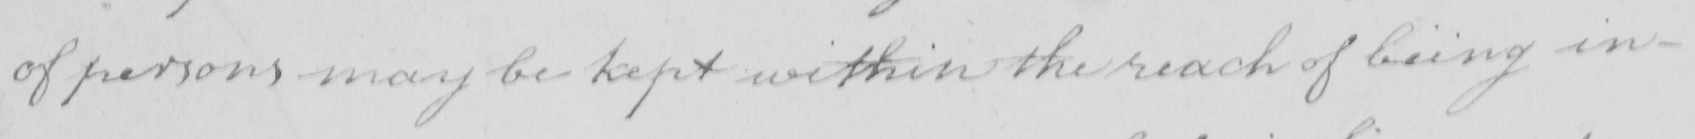Can you read and transcribe this handwriting? of persons may be kept within the reach of being in- 